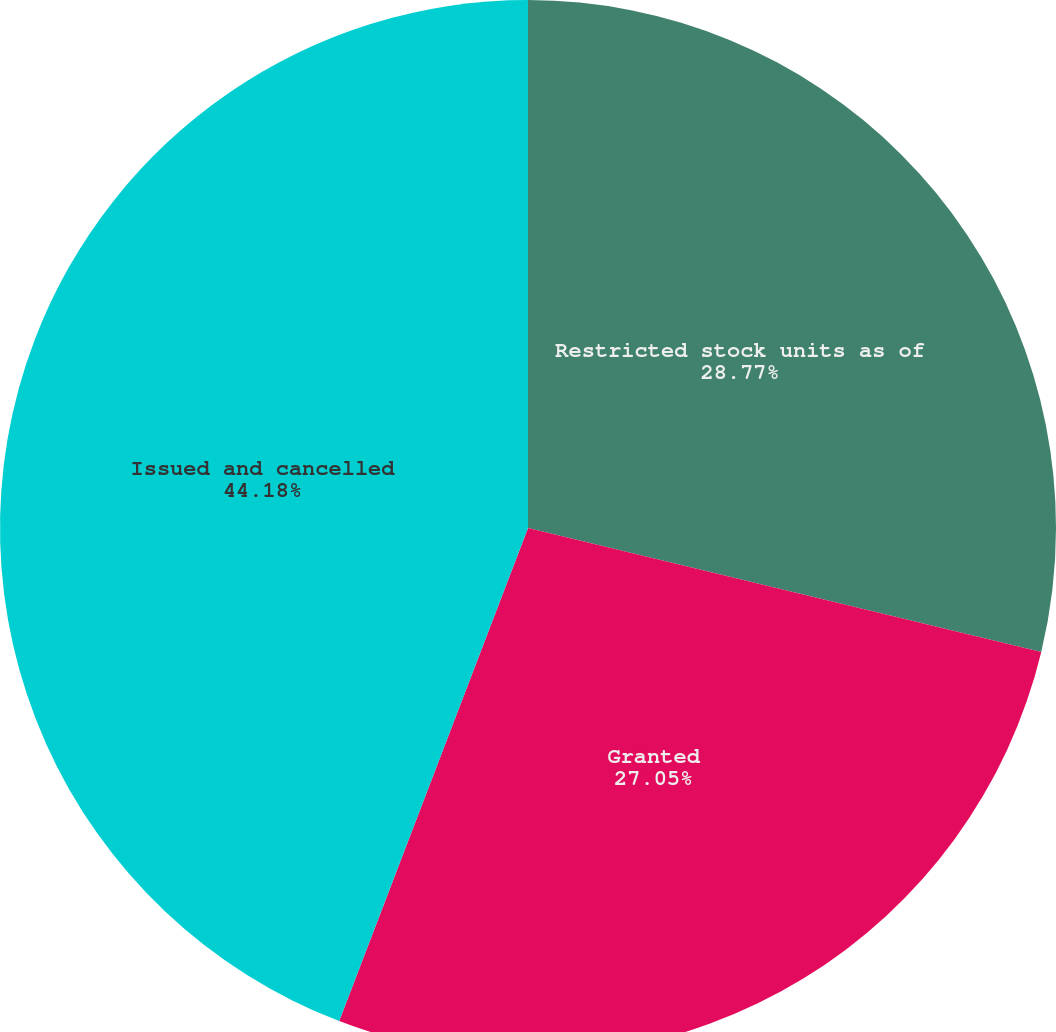Convert chart to OTSL. <chart><loc_0><loc_0><loc_500><loc_500><pie_chart><fcel>Restricted stock units as of<fcel>Granted<fcel>Issued and cancelled<nl><fcel>28.77%<fcel>27.05%<fcel>44.18%<nl></chart> 